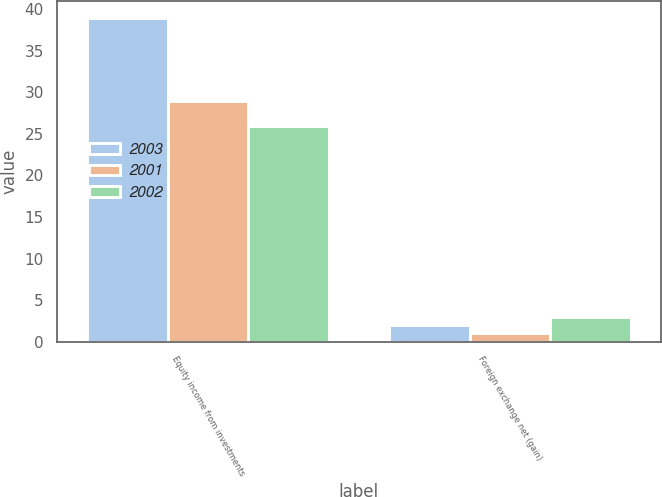<chart> <loc_0><loc_0><loc_500><loc_500><stacked_bar_chart><ecel><fcel>Equity income from investments<fcel>Foreign exchange net (gain)<nl><fcel>2003<fcel>39<fcel>2<nl><fcel>2001<fcel>29<fcel>1<nl><fcel>2002<fcel>26<fcel>3<nl></chart> 